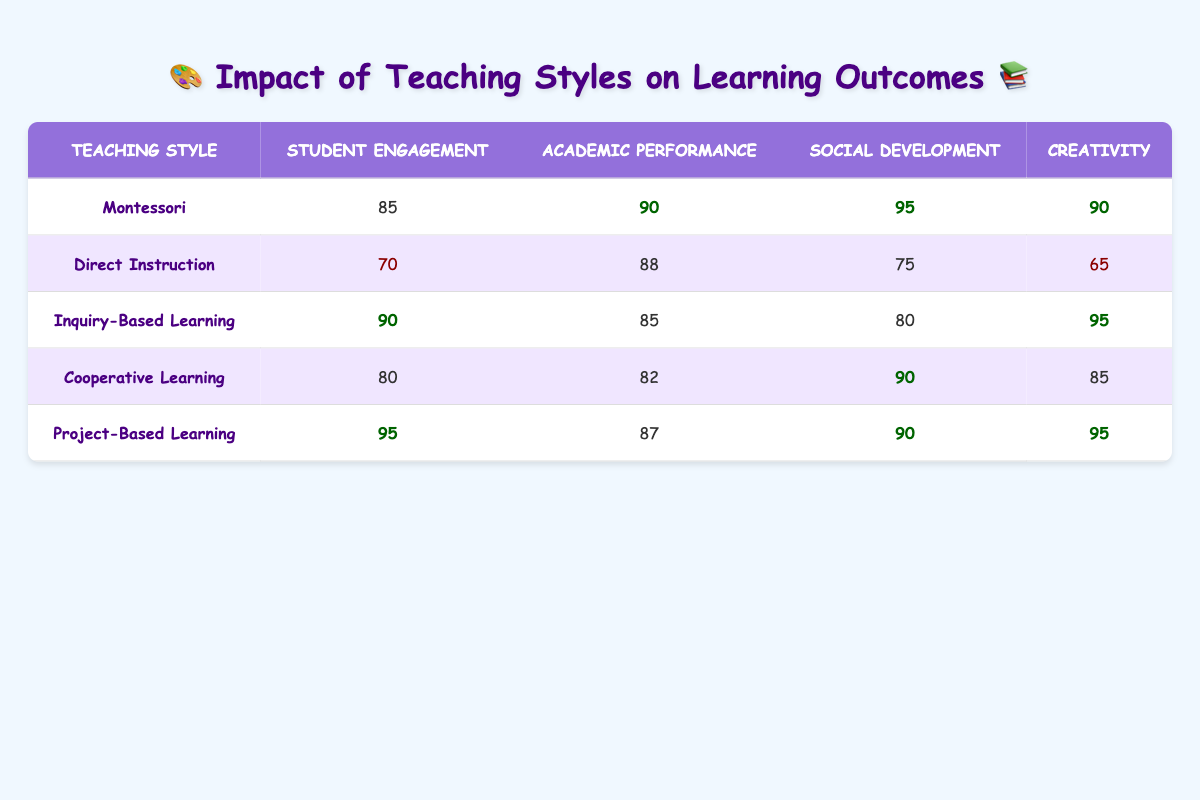What is the student engagement level for Montessori teaching style? Looking at the table under the "Student Engagement" column and finding the row for "Montessori," the value is 85.
Answer: 85 Which teaching style has the highest creativity score? By scanning down the "Creativity" column, we find that both Montessori and Project-Based Learning have scores of 90 and 95 respectively, making Project-Based Learning the highest.
Answer: Project-Based Learning What is the difference in academic performance between Inquiry-Based Learning and Direct Instruction? To find this, we look at the academic performance scores for both teaching styles: Inquiry-Based Learning is 85 and Direct Instruction is 88. The difference is calculated by subtracting 85 from 88, resulting in 3.
Answer: 3 True or False: Cooperative Learning has a higher social development score than Direct Instruction. In the table, the social development score for Cooperative Learning is 90 and for Direct Instruction is 75. Since 90 is greater than 75, the statement is true.
Answer: True What is the average student engagement score across all teaching styles? The student engagement scores are 85, 70, 90, 80, and 95. Adding these scores gives a total of 420. To find the average, we divide the total by the number of teaching styles, which is 5. Therefore, 420 divided by 5 equals 84.
Answer: 84 Which teaching style has the lowest social development score? By checking the "Social Development" column, Direct Instruction has the lowest score with a value of 75.
Answer: Direct Instruction If the creativity of Project-Based Learning were to improve by 5 points, what would be its new score? Project-Based Learning currently has a creativity score of 95. If it improves by 5 points, we simply add 5 to 95, resulting in a new score of 100.
Answer: 100 How does the average social development score compare between Montessori and Direct Instruction? Montessori has a social development score of 95 and Direct Instruction has a score of 75. To find the average of these two, we sum 95 and 75 to get 170, then divide by 2, resulting in an average of 85. The comparison shows that Montessori's score is higher than Direct Instruction's score.
Answer: Montessori is higher 